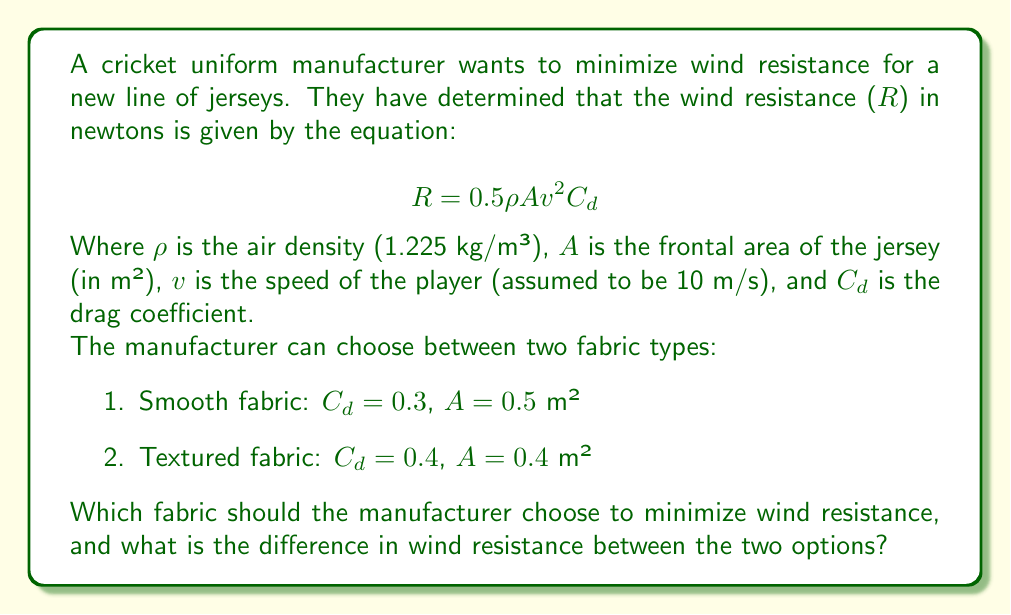Show me your answer to this math problem. To solve this problem, we need to calculate the wind resistance for each fabric type and compare them. Let's follow these steps:

1. Calculate wind resistance for smooth fabric:
   $$R_1 = 0.5 \cdot 1.225 \cdot 0.5 \cdot 10^2 \cdot 0.3$$
   $$R_1 = 9.1875 \text{ N}$$

2. Calculate wind resistance for textured fabric:
   $$R_2 = 0.5 \cdot 1.225 \cdot 0.4 \cdot 10^2 \cdot 0.4$$
   $$R_2 = 9.8 \text{ N}$$

3. Compare the results:
   The smooth fabric has lower wind resistance (9.1875 N) compared to the textured fabric (9.8 N).

4. Calculate the difference in wind resistance:
   $$\Delta R = R_2 - R_1 = 9.8 - 9.1875 = 0.6125 \text{ N}$$

Therefore, the manufacturer should choose the smooth fabric to minimize wind resistance. The difference in wind resistance between the two options is 0.6125 N.
Answer: The manufacturer should choose the smooth fabric. The difference in wind resistance between the two options is 0.6125 N. 